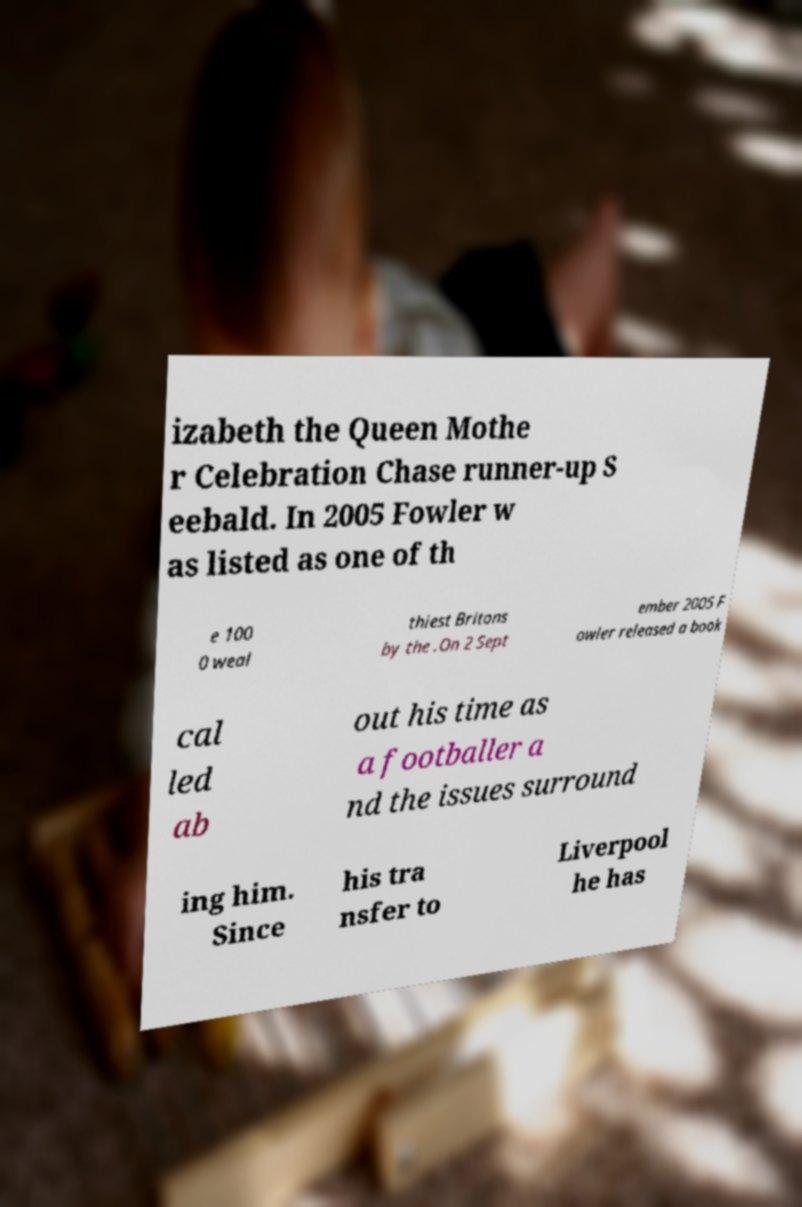Could you extract and type out the text from this image? izabeth the Queen Mothe r Celebration Chase runner-up S eebald. In 2005 Fowler w as listed as one of th e 100 0 weal thiest Britons by the .On 2 Sept ember 2005 F owler released a book cal led ab out his time as a footballer a nd the issues surround ing him. Since his tra nsfer to Liverpool he has 